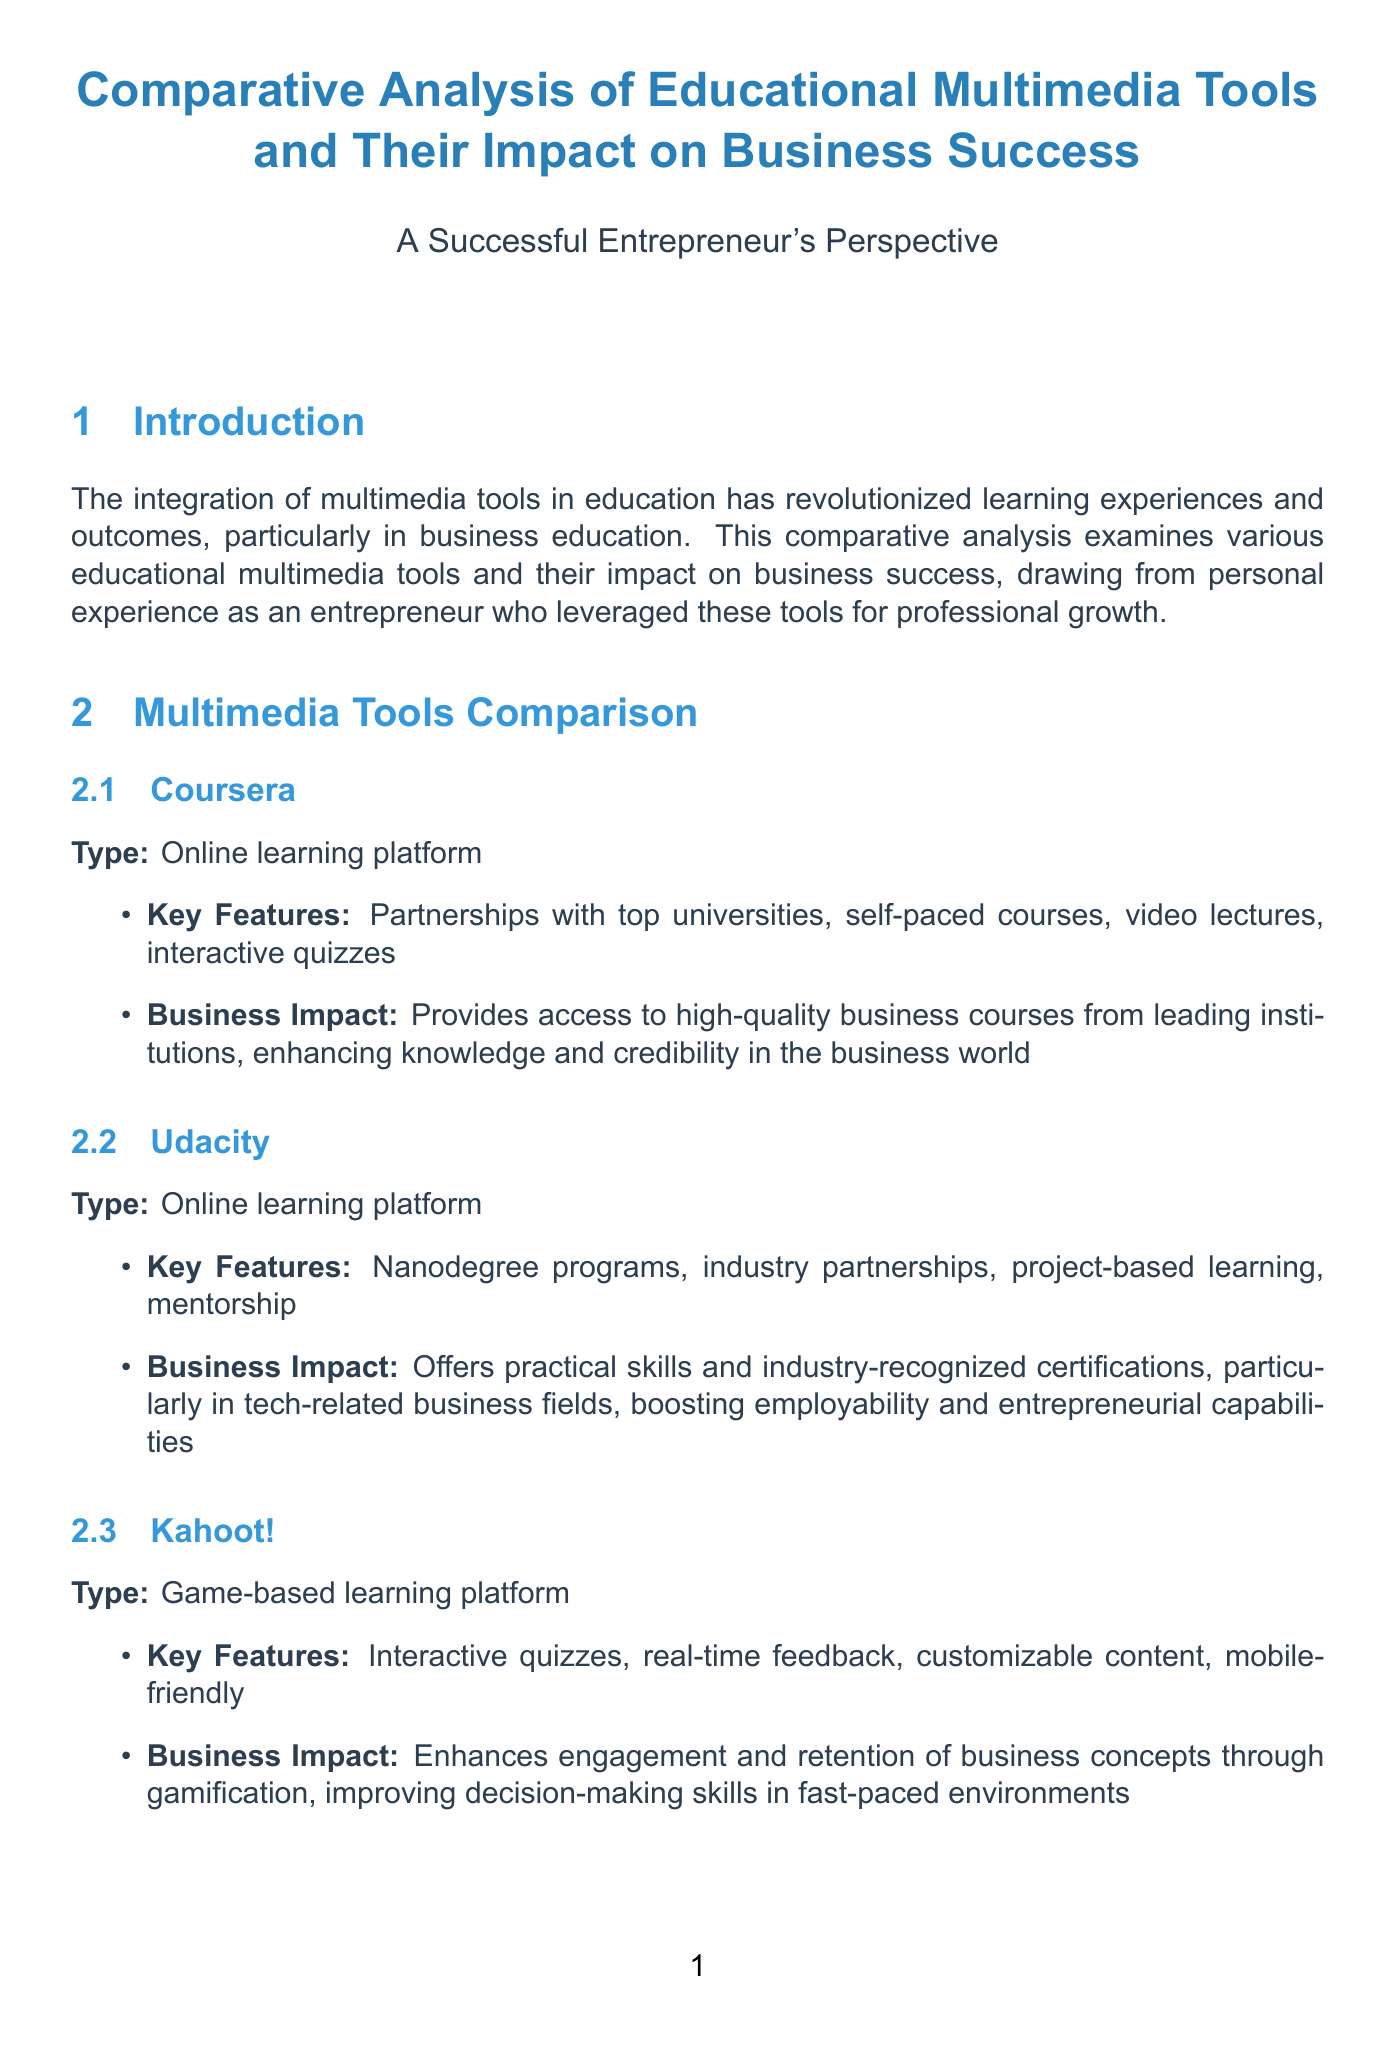What type of platform is Coursera? The document classifies Coursera as an "Online learning platform".
Answer: Online learning platform What is a key feature of Prezi? According to the document, one of the key features of Prezi is its "Zooming user interface".
Answer: Zooming user interface What business impact does Udacity have? The document states that Udacity "Offers practical skills and industry-recognized certifications".
Answer: Offers practical skills and industry-recognized certifications What percentage increase in productivity did Marcus Rodriguez's team experience? The document mentions a "30% increase in employee productivity".
Answer: 30% What future trend involves blockchain technology? The document discusses "Blockchain-based Credential Verification" as a future trend.
Answer: Blockchain-based Credential Verification Which tools did Sarah Chen use? The document specifies that Sarah Chen used "Coursera" and "Udacity".
Answer: Coursera, Udacity What is a challenge mentioned in the impact analysis? The document lists "Ensuring consistent engagement with self-paced learning" as a challenge.
Answer: Ensuring consistent engagement with self-paced learning What was the outcome of using Kahoot! in EcoVentures? The document states that it led to "successful expansion into three new markets".
Answer: successful expansion into three new markets 